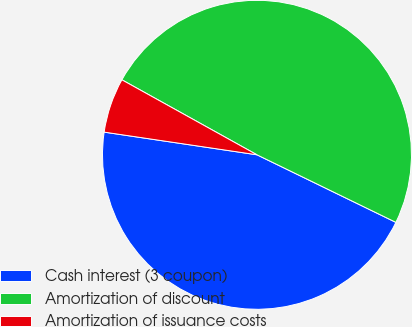Convert chart. <chart><loc_0><loc_0><loc_500><loc_500><pie_chart><fcel>Cash interest (3 coupon)<fcel>Amortization of discount<fcel>Amortization of issuance costs<nl><fcel>45.14%<fcel>49.14%<fcel>5.72%<nl></chart> 